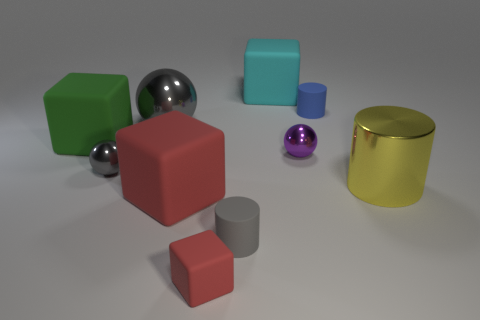Subtract all large green blocks. How many blocks are left? 3 Subtract all gray cylinders. How many cylinders are left? 2 Subtract 1 blocks. How many blocks are left? 3 Subtract all blocks. How many objects are left? 6 Subtract all yellow blocks. How many purple spheres are left? 1 Subtract all brown spheres. Subtract all purple cylinders. How many spheres are left? 3 Add 1 green blocks. How many green blocks exist? 2 Subtract 0 blue cubes. How many objects are left? 10 Subtract all small blue matte cylinders. Subtract all red rubber blocks. How many objects are left? 7 Add 6 large cylinders. How many large cylinders are left? 7 